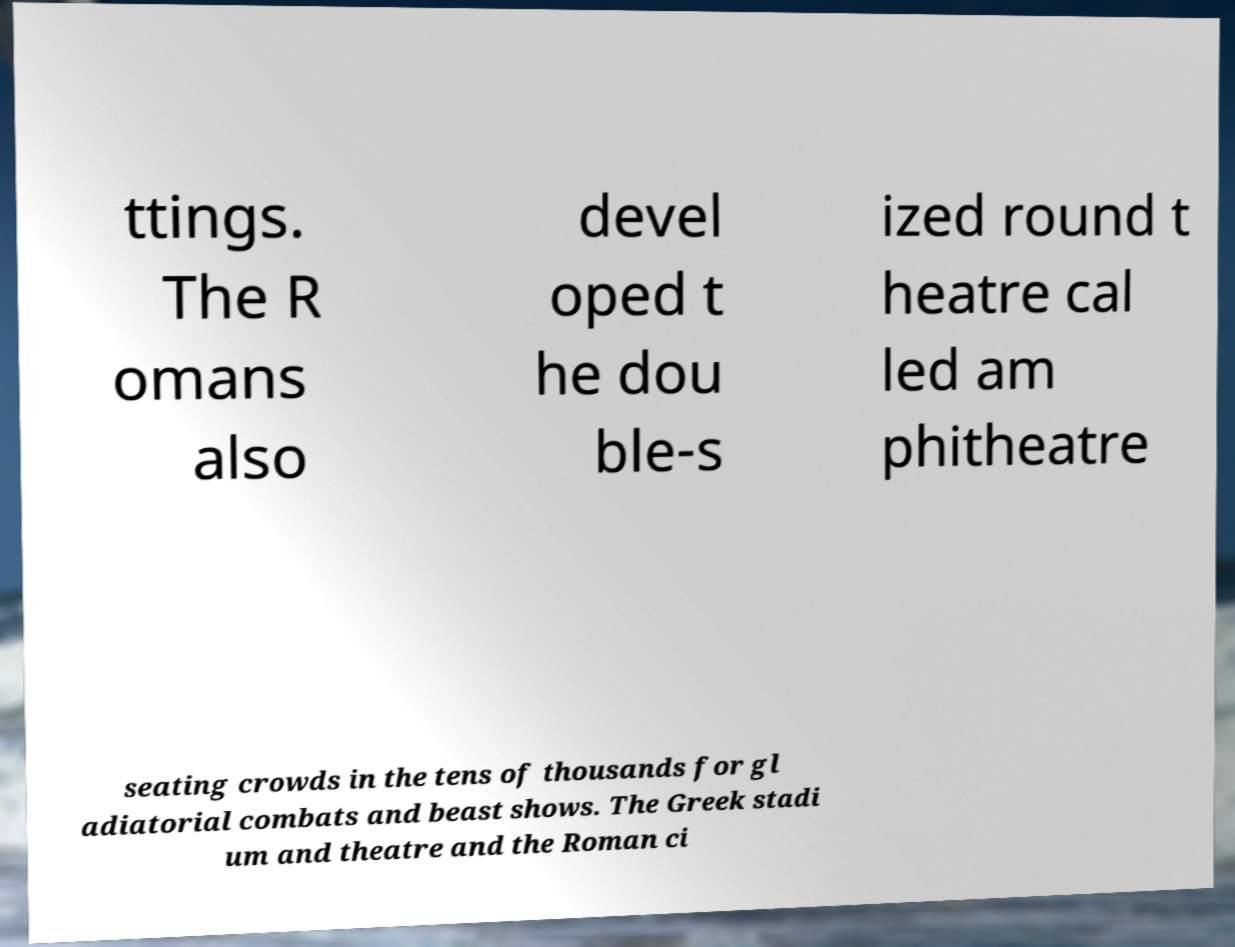Can you read and provide the text displayed in the image?This photo seems to have some interesting text. Can you extract and type it out for me? ttings. The R omans also devel oped t he dou ble-s ized round t heatre cal led am phitheatre seating crowds in the tens of thousands for gl adiatorial combats and beast shows. The Greek stadi um and theatre and the Roman ci 